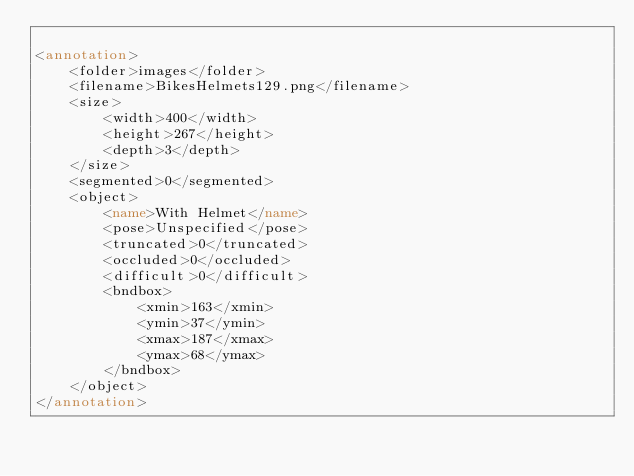<code> <loc_0><loc_0><loc_500><loc_500><_XML_>
<annotation>
    <folder>images</folder>
    <filename>BikesHelmets129.png</filename>
    <size>
        <width>400</width>
        <height>267</height>
        <depth>3</depth>
    </size>
    <segmented>0</segmented>
    <object>
        <name>With Helmet</name>
        <pose>Unspecified</pose>
        <truncated>0</truncated>
        <occluded>0</occluded>
        <difficult>0</difficult>
        <bndbox>
            <xmin>163</xmin>
            <ymin>37</ymin>
            <xmax>187</xmax>
            <ymax>68</ymax>
        </bndbox>
    </object>
</annotation></code> 